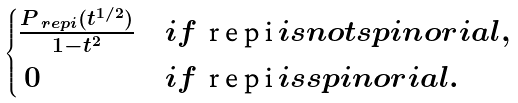<formula> <loc_0><loc_0><loc_500><loc_500>\begin{cases} \frac { P _ { \ r e p i } ( t ^ { 1 / 2 } ) } { 1 - t ^ { 2 } } & i f $ \ r e p i $ i s n o t s p i n o r i a l , \\ \ 0 & i f $ \ r e p i $ i s s p i n o r i a l . \end{cases}</formula> 